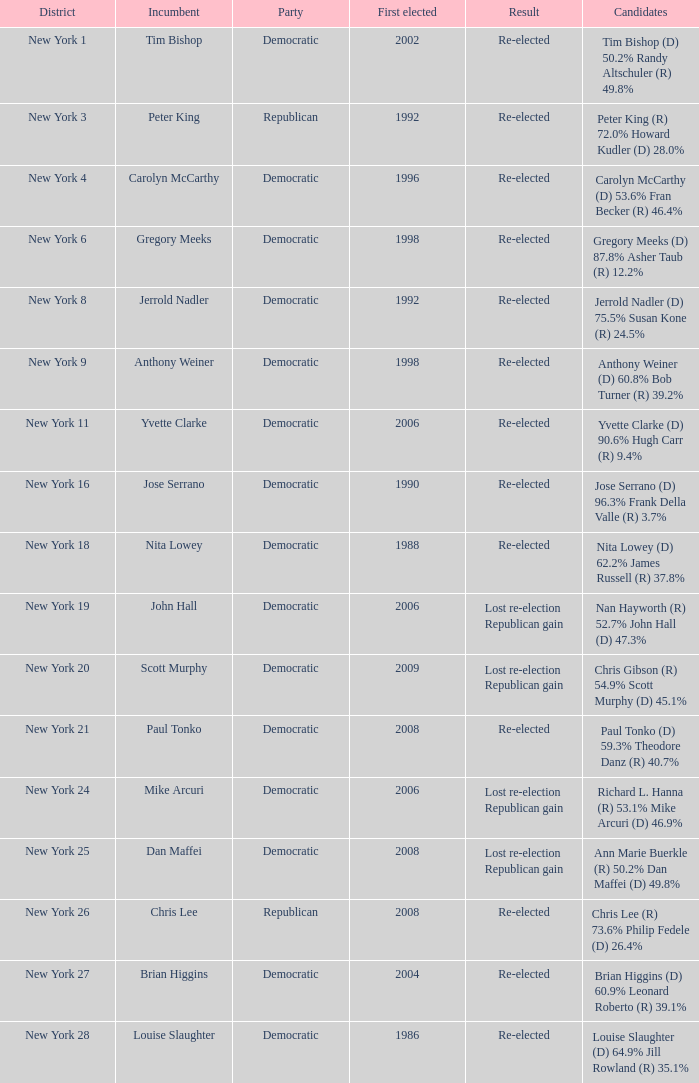Specify the count of party for richard l. hanna (r) 5 1.0. 